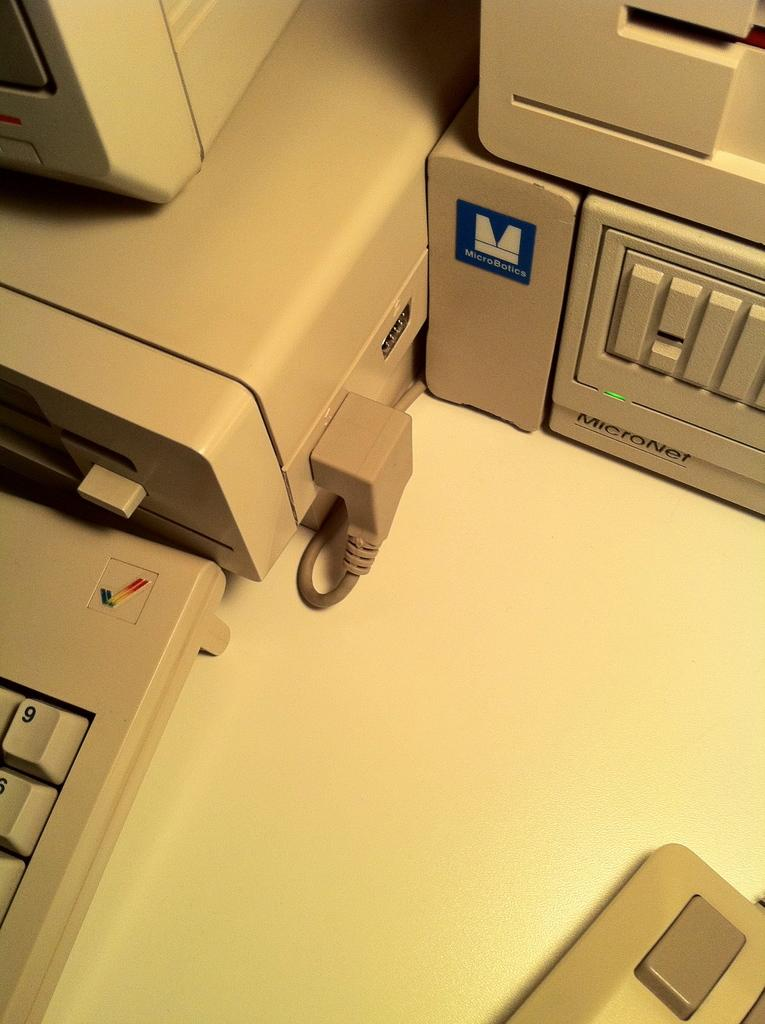<image>
Create a compact narrative representing the image presented. an old fashioned computer with the number nine visible on the keyboard 